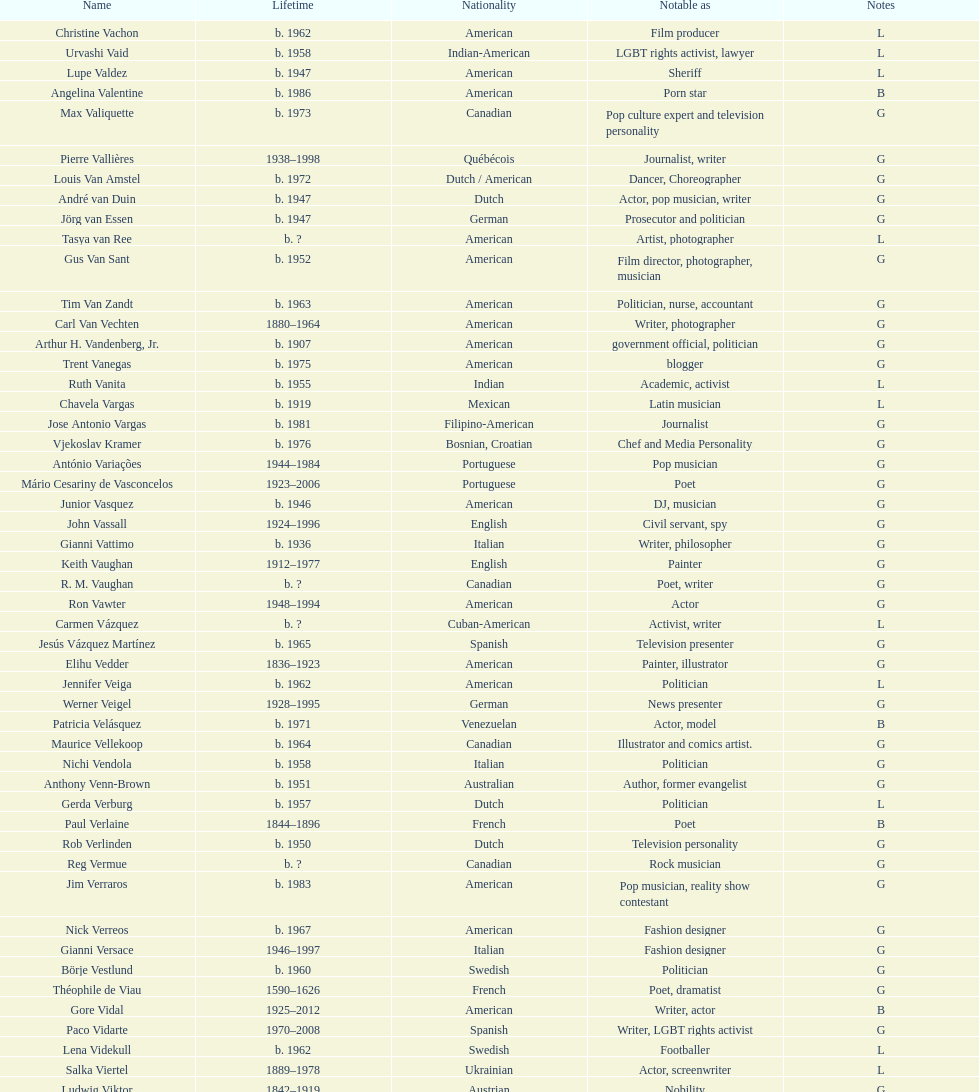What is the number of individuals in this group who were indian? 1. 